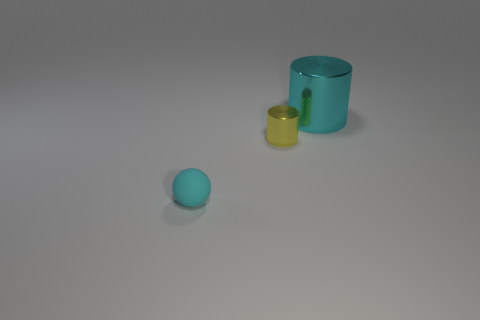Add 3 big brown metal cylinders. How many objects exist? 6 Subtract all spheres. How many objects are left? 2 Add 3 big cyan metallic cylinders. How many big cyan metallic cylinders exist? 4 Subtract 0 blue cylinders. How many objects are left? 3 Subtract all tiny blue cylinders. Subtract all tiny yellow shiny cylinders. How many objects are left? 2 Add 1 cyan shiny things. How many cyan shiny things are left? 2 